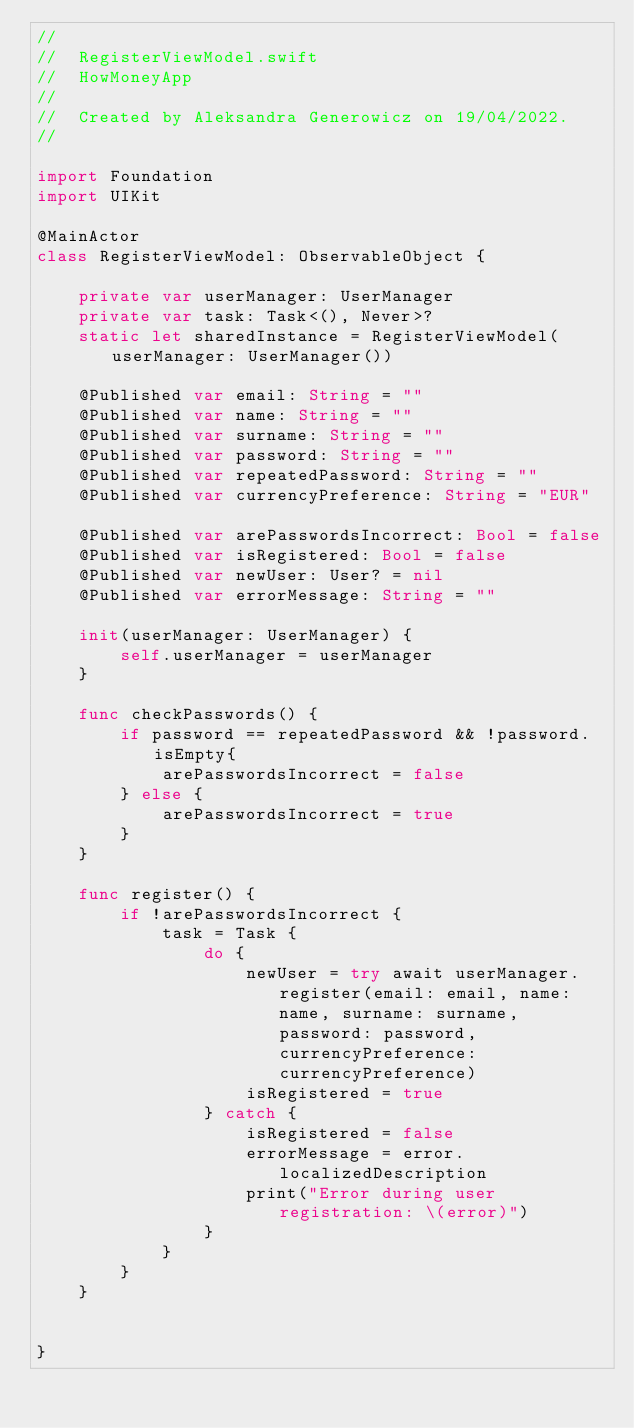Convert code to text. <code><loc_0><loc_0><loc_500><loc_500><_Swift_>//
//  RegisterViewModel.swift
//  HowMoneyApp
//
//  Created by Aleksandra Generowicz on 19/04/2022.
//

import Foundation
import UIKit

@MainActor
class RegisterViewModel: ObservableObject {
    
    private var userManager: UserManager
    private var task: Task<(), Never>?
    static let sharedInstance = RegisterViewModel(userManager: UserManager())
    
    @Published var email: String = ""
    @Published var name: String = ""
    @Published var surname: String = ""
    @Published var password: String = ""
    @Published var repeatedPassword: String = ""
    @Published var currencyPreference: String = "EUR"
    
    @Published var arePasswordsIncorrect: Bool = false
    @Published var isRegistered: Bool = false
    @Published var newUser: User? = nil
    @Published var errorMessage: String = ""
    
    init(userManager: UserManager) {
        self.userManager = userManager
    }
    
    func checkPasswords() {
        if password == repeatedPassword && !password.isEmpty{
            arePasswordsIncorrect = false
        } else {
            arePasswordsIncorrect = true
        }
    }
    
    func register() {
        if !arePasswordsIncorrect {
            task = Task {
                do {
                    newUser = try await userManager.register(email: email, name: name, surname: surname, password: password, currencyPreference: currencyPreference)
                    isRegistered = true
                } catch {
                    isRegistered = false
                    errorMessage = error.localizedDescription
                    print("Error during user registration: \(error)")
                }
            }
        }
    }
    
    
}
</code> 